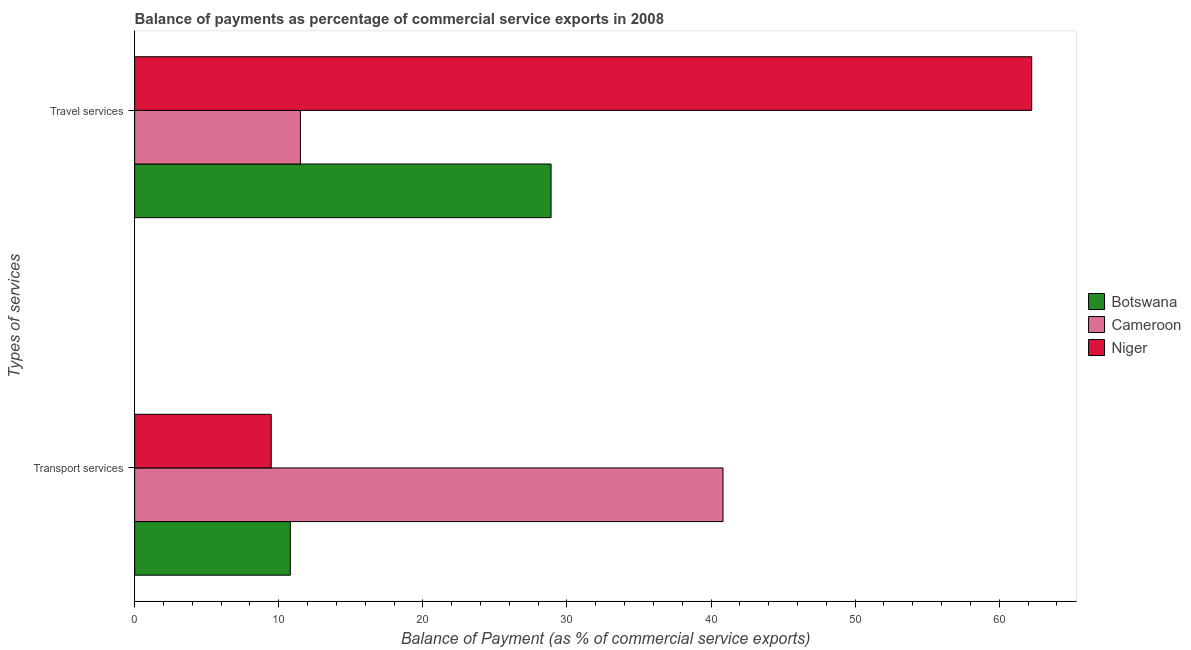How many groups of bars are there?
Your answer should be very brief. 2. Are the number of bars per tick equal to the number of legend labels?
Your answer should be very brief. Yes. Are the number of bars on each tick of the Y-axis equal?
Your answer should be compact. Yes. How many bars are there on the 2nd tick from the top?
Make the answer very short. 3. How many bars are there on the 1st tick from the bottom?
Give a very brief answer. 3. What is the label of the 2nd group of bars from the top?
Keep it short and to the point. Transport services. What is the balance of payments of transport services in Botswana?
Your answer should be very brief. 10.8. Across all countries, what is the maximum balance of payments of transport services?
Your response must be concise. 40.83. Across all countries, what is the minimum balance of payments of transport services?
Give a very brief answer. 9.48. In which country was the balance of payments of transport services maximum?
Keep it short and to the point. Cameroon. In which country was the balance of payments of transport services minimum?
Offer a very short reply. Niger. What is the total balance of payments of travel services in the graph?
Ensure brevity in your answer.  102.66. What is the difference between the balance of payments of travel services in Niger and that in Botswana?
Offer a very short reply. 33.36. What is the difference between the balance of payments of transport services in Cameroon and the balance of payments of travel services in Botswana?
Make the answer very short. 11.93. What is the average balance of payments of travel services per country?
Ensure brevity in your answer.  34.22. What is the difference between the balance of payments of travel services and balance of payments of transport services in Cameroon?
Your answer should be very brief. -29.33. In how many countries, is the balance of payments of travel services greater than 4 %?
Your answer should be compact. 3. What is the ratio of the balance of payments of transport services in Botswana to that in Cameroon?
Your answer should be compact. 0.26. Is the balance of payments of travel services in Cameroon less than that in Botswana?
Ensure brevity in your answer.  Yes. In how many countries, is the balance of payments of travel services greater than the average balance of payments of travel services taken over all countries?
Provide a succinct answer. 1. What does the 2nd bar from the top in Travel services represents?
Your response must be concise. Cameroon. What does the 2nd bar from the bottom in Transport services represents?
Your answer should be very brief. Cameroon. How many bars are there?
Offer a very short reply. 6. Are all the bars in the graph horizontal?
Ensure brevity in your answer.  Yes. How many countries are there in the graph?
Offer a very short reply. 3. Does the graph contain any zero values?
Your answer should be very brief. No. How are the legend labels stacked?
Your response must be concise. Vertical. What is the title of the graph?
Give a very brief answer. Balance of payments as percentage of commercial service exports in 2008. What is the label or title of the X-axis?
Give a very brief answer. Balance of Payment (as % of commercial service exports). What is the label or title of the Y-axis?
Ensure brevity in your answer.  Types of services. What is the Balance of Payment (as % of commercial service exports) in Botswana in Transport services?
Offer a terse response. 10.8. What is the Balance of Payment (as % of commercial service exports) in Cameroon in Transport services?
Make the answer very short. 40.83. What is the Balance of Payment (as % of commercial service exports) in Niger in Transport services?
Offer a very short reply. 9.48. What is the Balance of Payment (as % of commercial service exports) of Botswana in Travel services?
Give a very brief answer. 28.9. What is the Balance of Payment (as % of commercial service exports) of Cameroon in Travel services?
Give a very brief answer. 11.5. What is the Balance of Payment (as % of commercial service exports) of Niger in Travel services?
Ensure brevity in your answer.  62.26. Across all Types of services, what is the maximum Balance of Payment (as % of commercial service exports) in Botswana?
Your answer should be compact. 28.9. Across all Types of services, what is the maximum Balance of Payment (as % of commercial service exports) of Cameroon?
Make the answer very short. 40.83. Across all Types of services, what is the maximum Balance of Payment (as % of commercial service exports) of Niger?
Offer a terse response. 62.26. Across all Types of services, what is the minimum Balance of Payment (as % of commercial service exports) in Botswana?
Your answer should be very brief. 10.8. Across all Types of services, what is the minimum Balance of Payment (as % of commercial service exports) of Cameroon?
Offer a terse response. 11.5. Across all Types of services, what is the minimum Balance of Payment (as % of commercial service exports) in Niger?
Offer a very short reply. 9.48. What is the total Balance of Payment (as % of commercial service exports) in Botswana in the graph?
Keep it short and to the point. 39.71. What is the total Balance of Payment (as % of commercial service exports) in Cameroon in the graph?
Ensure brevity in your answer.  52.34. What is the total Balance of Payment (as % of commercial service exports) of Niger in the graph?
Offer a very short reply. 71.73. What is the difference between the Balance of Payment (as % of commercial service exports) in Botswana in Transport services and that in Travel services?
Keep it short and to the point. -18.1. What is the difference between the Balance of Payment (as % of commercial service exports) of Cameroon in Transport services and that in Travel services?
Keep it short and to the point. 29.33. What is the difference between the Balance of Payment (as % of commercial service exports) in Niger in Transport services and that in Travel services?
Your answer should be compact. -52.78. What is the difference between the Balance of Payment (as % of commercial service exports) in Botswana in Transport services and the Balance of Payment (as % of commercial service exports) in Cameroon in Travel services?
Your answer should be compact. -0.7. What is the difference between the Balance of Payment (as % of commercial service exports) in Botswana in Transport services and the Balance of Payment (as % of commercial service exports) in Niger in Travel services?
Your response must be concise. -51.45. What is the difference between the Balance of Payment (as % of commercial service exports) of Cameroon in Transport services and the Balance of Payment (as % of commercial service exports) of Niger in Travel services?
Offer a terse response. -21.42. What is the average Balance of Payment (as % of commercial service exports) of Botswana per Types of services?
Provide a succinct answer. 19.85. What is the average Balance of Payment (as % of commercial service exports) of Cameroon per Types of services?
Your response must be concise. 26.17. What is the average Balance of Payment (as % of commercial service exports) of Niger per Types of services?
Keep it short and to the point. 35.87. What is the difference between the Balance of Payment (as % of commercial service exports) in Botswana and Balance of Payment (as % of commercial service exports) in Cameroon in Transport services?
Provide a succinct answer. -30.03. What is the difference between the Balance of Payment (as % of commercial service exports) of Botswana and Balance of Payment (as % of commercial service exports) of Niger in Transport services?
Your response must be concise. 1.33. What is the difference between the Balance of Payment (as % of commercial service exports) of Cameroon and Balance of Payment (as % of commercial service exports) of Niger in Transport services?
Ensure brevity in your answer.  31.36. What is the difference between the Balance of Payment (as % of commercial service exports) in Botswana and Balance of Payment (as % of commercial service exports) in Cameroon in Travel services?
Offer a very short reply. 17.4. What is the difference between the Balance of Payment (as % of commercial service exports) in Botswana and Balance of Payment (as % of commercial service exports) in Niger in Travel services?
Offer a very short reply. -33.36. What is the difference between the Balance of Payment (as % of commercial service exports) of Cameroon and Balance of Payment (as % of commercial service exports) of Niger in Travel services?
Offer a terse response. -50.75. What is the ratio of the Balance of Payment (as % of commercial service exports) of Botswana in Transport services to that in Travel services?
Your answer should be very brief. 0.37. What is the ratio of the Balance of Payment (as % of commercial service exports) in Cameroon in Transport services to that in Travel services?
Make the answer very short. 3.55. What is the ratio of the Balance of Payment (as % of commercial service exports) of Niger in Transport services to that in Travel services?
Provide a short and direct response. 0.15. What is the difference between the highest and the second highest Balance of Payment (as % of commercial service exports) in Botswana?
Ensure brevity in your answer.  18.1. What is the difference between the highest and the second highest Balance of Payment (as % of commercial service exports) in Cameroon?
Your answer should be very brief. 29.33. What is the difference between the highest and the second highest Balance of Payment (as % of commercial service exports) of Niger?
Give a very brief answer. 52.78. What is the difference between the highest and the lowest Balance of Payment (as % of commercial service exports) in Botswana?
Your response must be concise. 18.1. What is the difference between the highest and the lowest Balance of Payment (as % of commercial service exports) of Cameroon?
Your answer should be compact. 29.33. What is the difference between the highest and the lowest Balance of Payment (as % of commercial service exports) in Niger?
Ensure brevity in your answer.  52.78. 